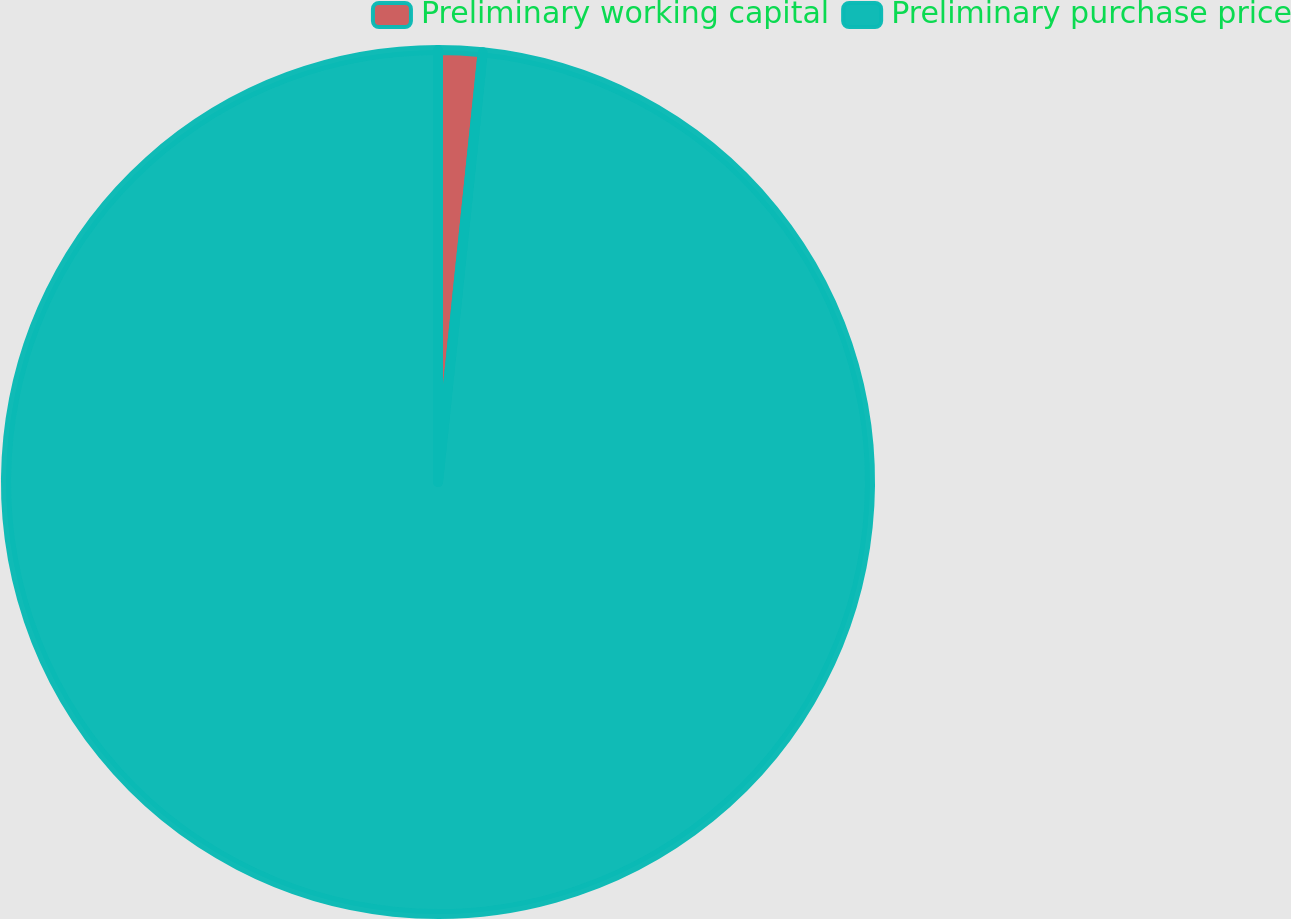Convert chart to OTSL. <chart><loc_0><loc_0><loc_500><loc_500><pie_chart><fcel>Preliminary working capital<fcel>Preliminary purchase price<nl><fcel>1.65%<fcel>98.35%<nl></chart> 